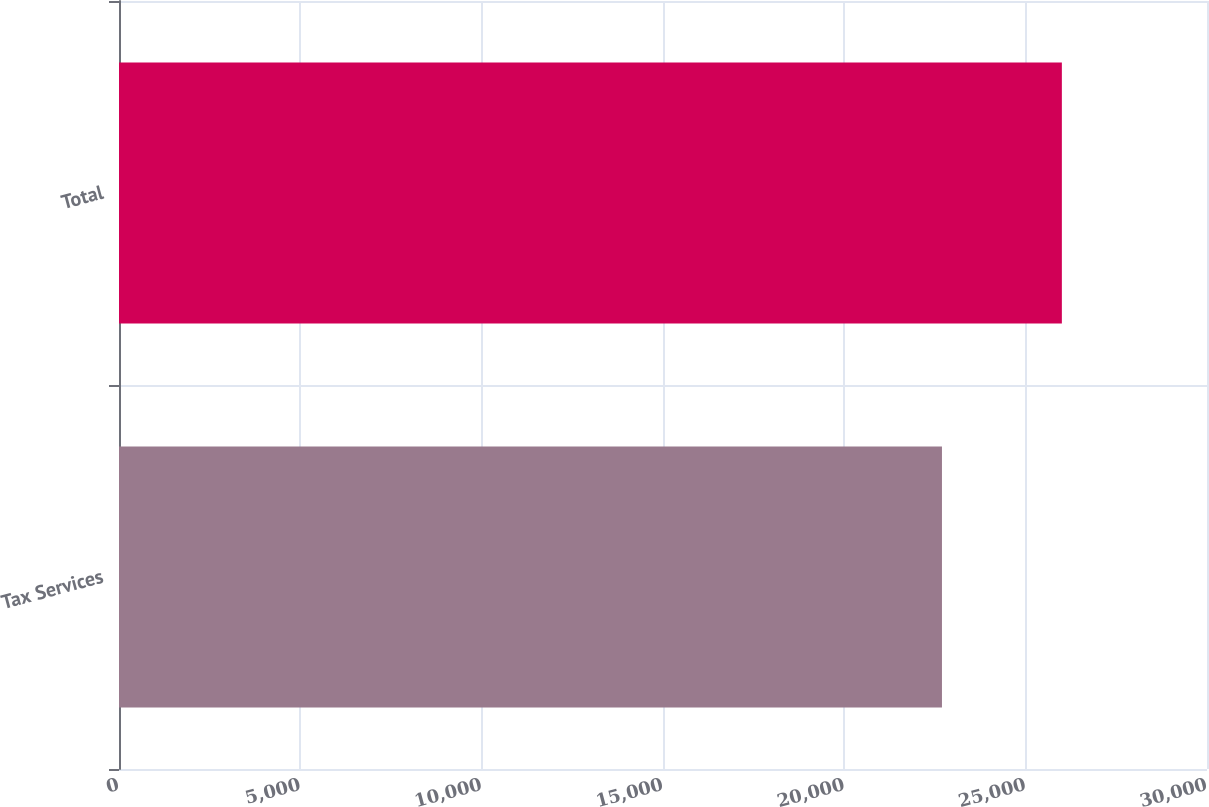<chart> <loc_0><loc_0><loc_500><loc_500><bar_chart><fcel>Tax Services<fcel>Total<nl><fcel>22692<fcel>25998<nl></chart> 